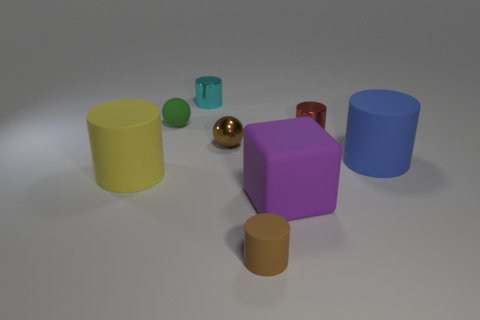Are there an equal number of big blue rubber cylinders that are behind the shiny ball and blue cylinders left of the yellow object?
Keep it short and to the point. Yes. There is a tiny object that is the same color as the metallic sphere; what is its shape?
Offer a very short reply. Cylinder. What material is the brown thing behind the big yellow cylinder?
Give a very brief answer. Metal. Do the cyan cylinder and the red metal cylinder have the same size?
Your response must be concise. Yes. Are there more green spheres that are in front of the brown metallic sphere than brown matte cylinders?
Keep it short and to the point. No. What size is the blue object that is made of the same material as the yellow object?
Keep it short and to the point. Large. There is a blue matte cylinder; are there any tiny red shiny things in front of it?
Provide a short and direct response. No. Is the shape of the tiny cyan thing the same as the red thing?
Your response must be concise. Yes. What size is the brown object that is behind the large rubber cylinder to the left of the large rubber cylinder that is to the right of the red metal object?
Your answer should be very brief. Small. What material is the brown cylinder?
Give a very brief answer. Rubber. 